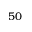<formula> <loc_0><loc_0><loc_500><loc_500>5 0</formula> 